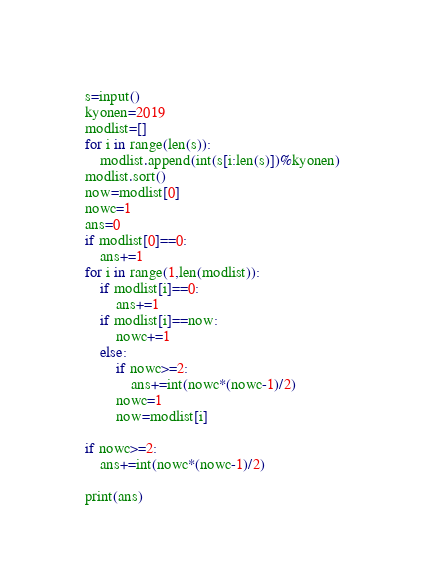Convert code to text. <code><loc_0><loc_0><loc_500><loc_500><_Python_>s=input()
kyonen=2019
modlist=[]
for i in range(len(s)):
    modlist.append(int(s[i:len(s)])%kyonen)
modlist.sort()
now=modlist[0]
nowc=1
ans=0
if modlist[0]==0:
    ans+=1
for i in range(1,len(modlist)):
    if modlist[i]==0:
        ans+=1
    if modlist[i]==now:
        nowc+=1
    else:
        if nowc>=2:
            ans+=int(nowc*(nowc-1)/2)
        nowc=1
        now=modlist[i]

if nowc>=2:
    ans+=int(nowc*(nowc-1)/2)

print(ans)</code> 